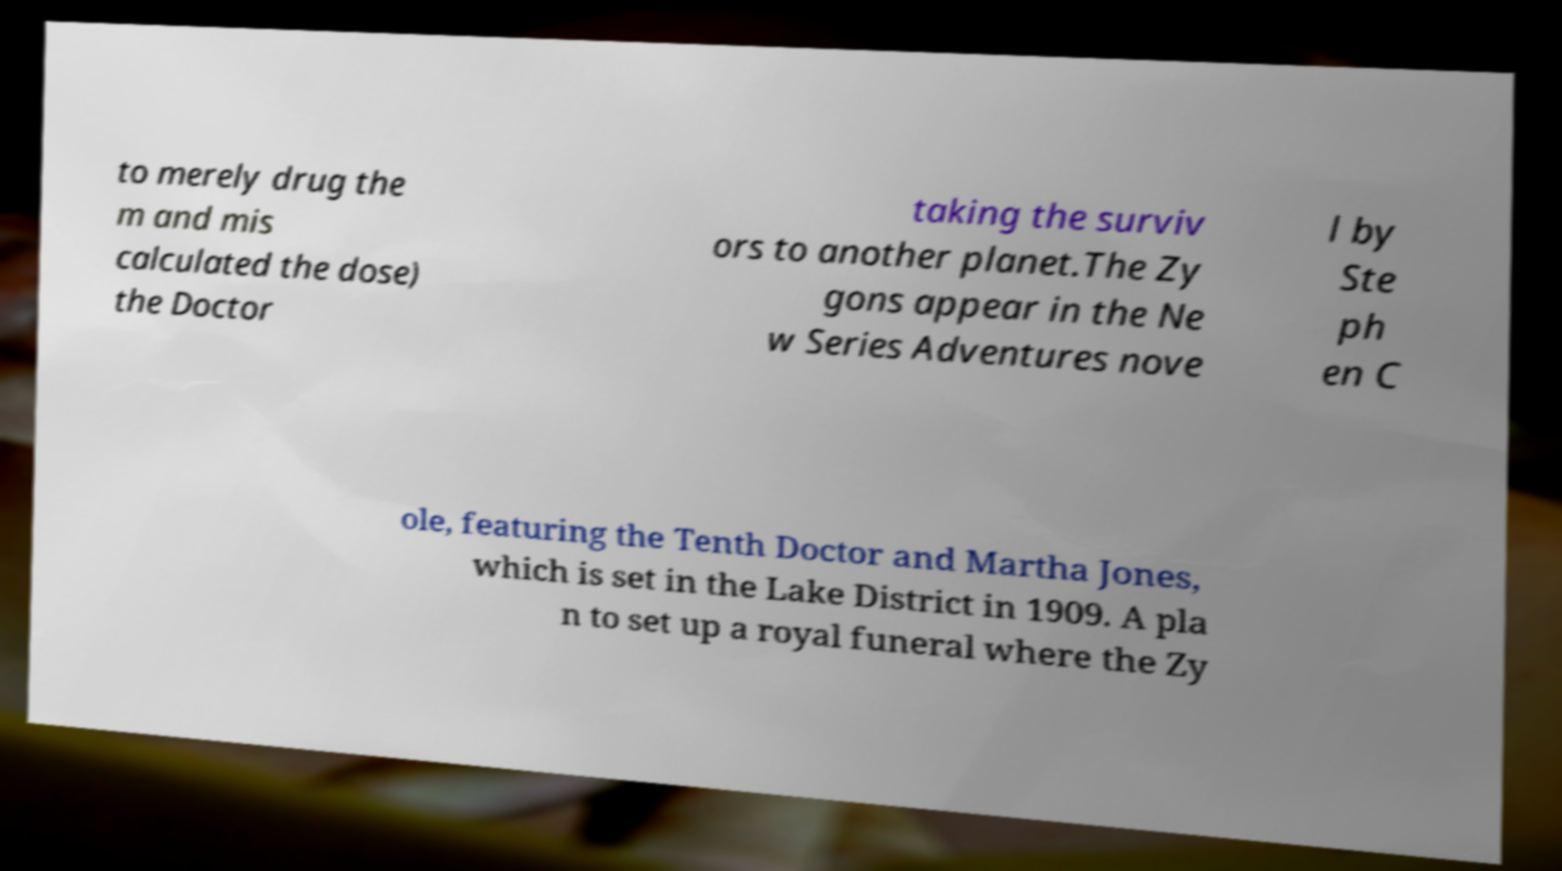Can you accurately transcribe the text from the provided image for me? to merely drug the m and mis calculated the dose) the Doctor taking the surviv ors to another planet.The Zy gons appear in the Ne w Series Adventures nove l by Ste ph en C ole, featuring the Tenth Doctor and Martha Jones, which is set in the Lake District in 1909. A pla n to set up a royal funeral where the Zy 